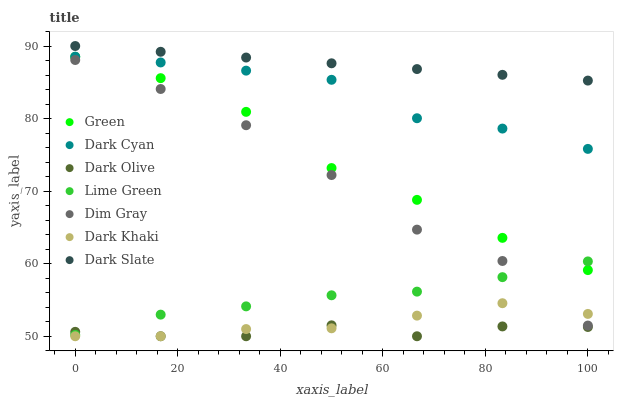Does Dark Olive have the minimum area under the curve?
Answer yes or no. Yes. Does Dark Slate have the maximum area under the curve?
Answer yes or no. Yes. Does Dark Khaki have the minimum area under the curve?
Answer yes or no. No. Does Dark Khaki have the maximum area under the curve?
Answer yes or no. No. Is Dark Slate the smoothest?
Answer yes or no. Yes. Is Dim Gray the roughest?
Answer yes or no. Yes. Is Dark Olive the smoothest?
Answer yes or no. No. Is Dark Olive the roughest?
Answer yes or no. No. Does Dark Olive have the lowest value?
Answer yes or no. Yes. Does Dark Slate have the lowest value?
Answer yes or no. No. Does Dark Slate have the highest value?
Answer yes or no. Yes. Does Dark Khaki have the highest value?
Answer yes or no. No. Is Dim Gray less than Green?
Answer yes or no. Yes. Is Dark Cyan greater than Dark Khaki?
Answer yes or no. Yes. Does Dark Khaki intersect Dim Gray?
Answer yes or no. Yes. Is Dark Khaki less than Dim Gray?
Answer yes or no. No. Is Dark Khaki greater than Dim Gray?
Answer yes or no. No. Does Dim Gray intersect Green?
Answer yes or no. No. 